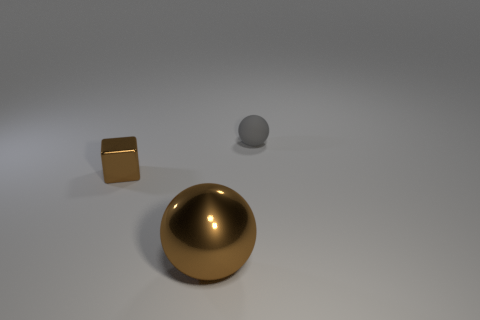Add 3 big red metal spheres. How many objects exist? 6 Subtract all gray spheres. How many spheres are left? 1 Subtract 0 cyan spheres. How many objects are left? 3 Subtract all balls. How many objects are left? 1 Subtract all red balls. Subtract all purple blocks. How many balls are left? 2 Subtract all gray cubes. How many gray balls are left? 1 Subtract all brown shiny cubes. Subtract all large objects. How many objects are left? 1 Add 2 blocks. How many blocks are left? 3 Add 1 tiny yellow cubes. How many tiny yellow cubes exist? 1 